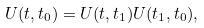<formula> <loc_0><loc_0><loc_500><loc_500>U ( t , t _ { 0 } ) = U ( t , t _ { 1 } ) U ( t _ { 1 } , t _ { 0 } ) ,</formula> 